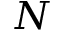Convert formula to latex. <formula><loc_0><loc_0><loc_500><loc_500>N</formula> 